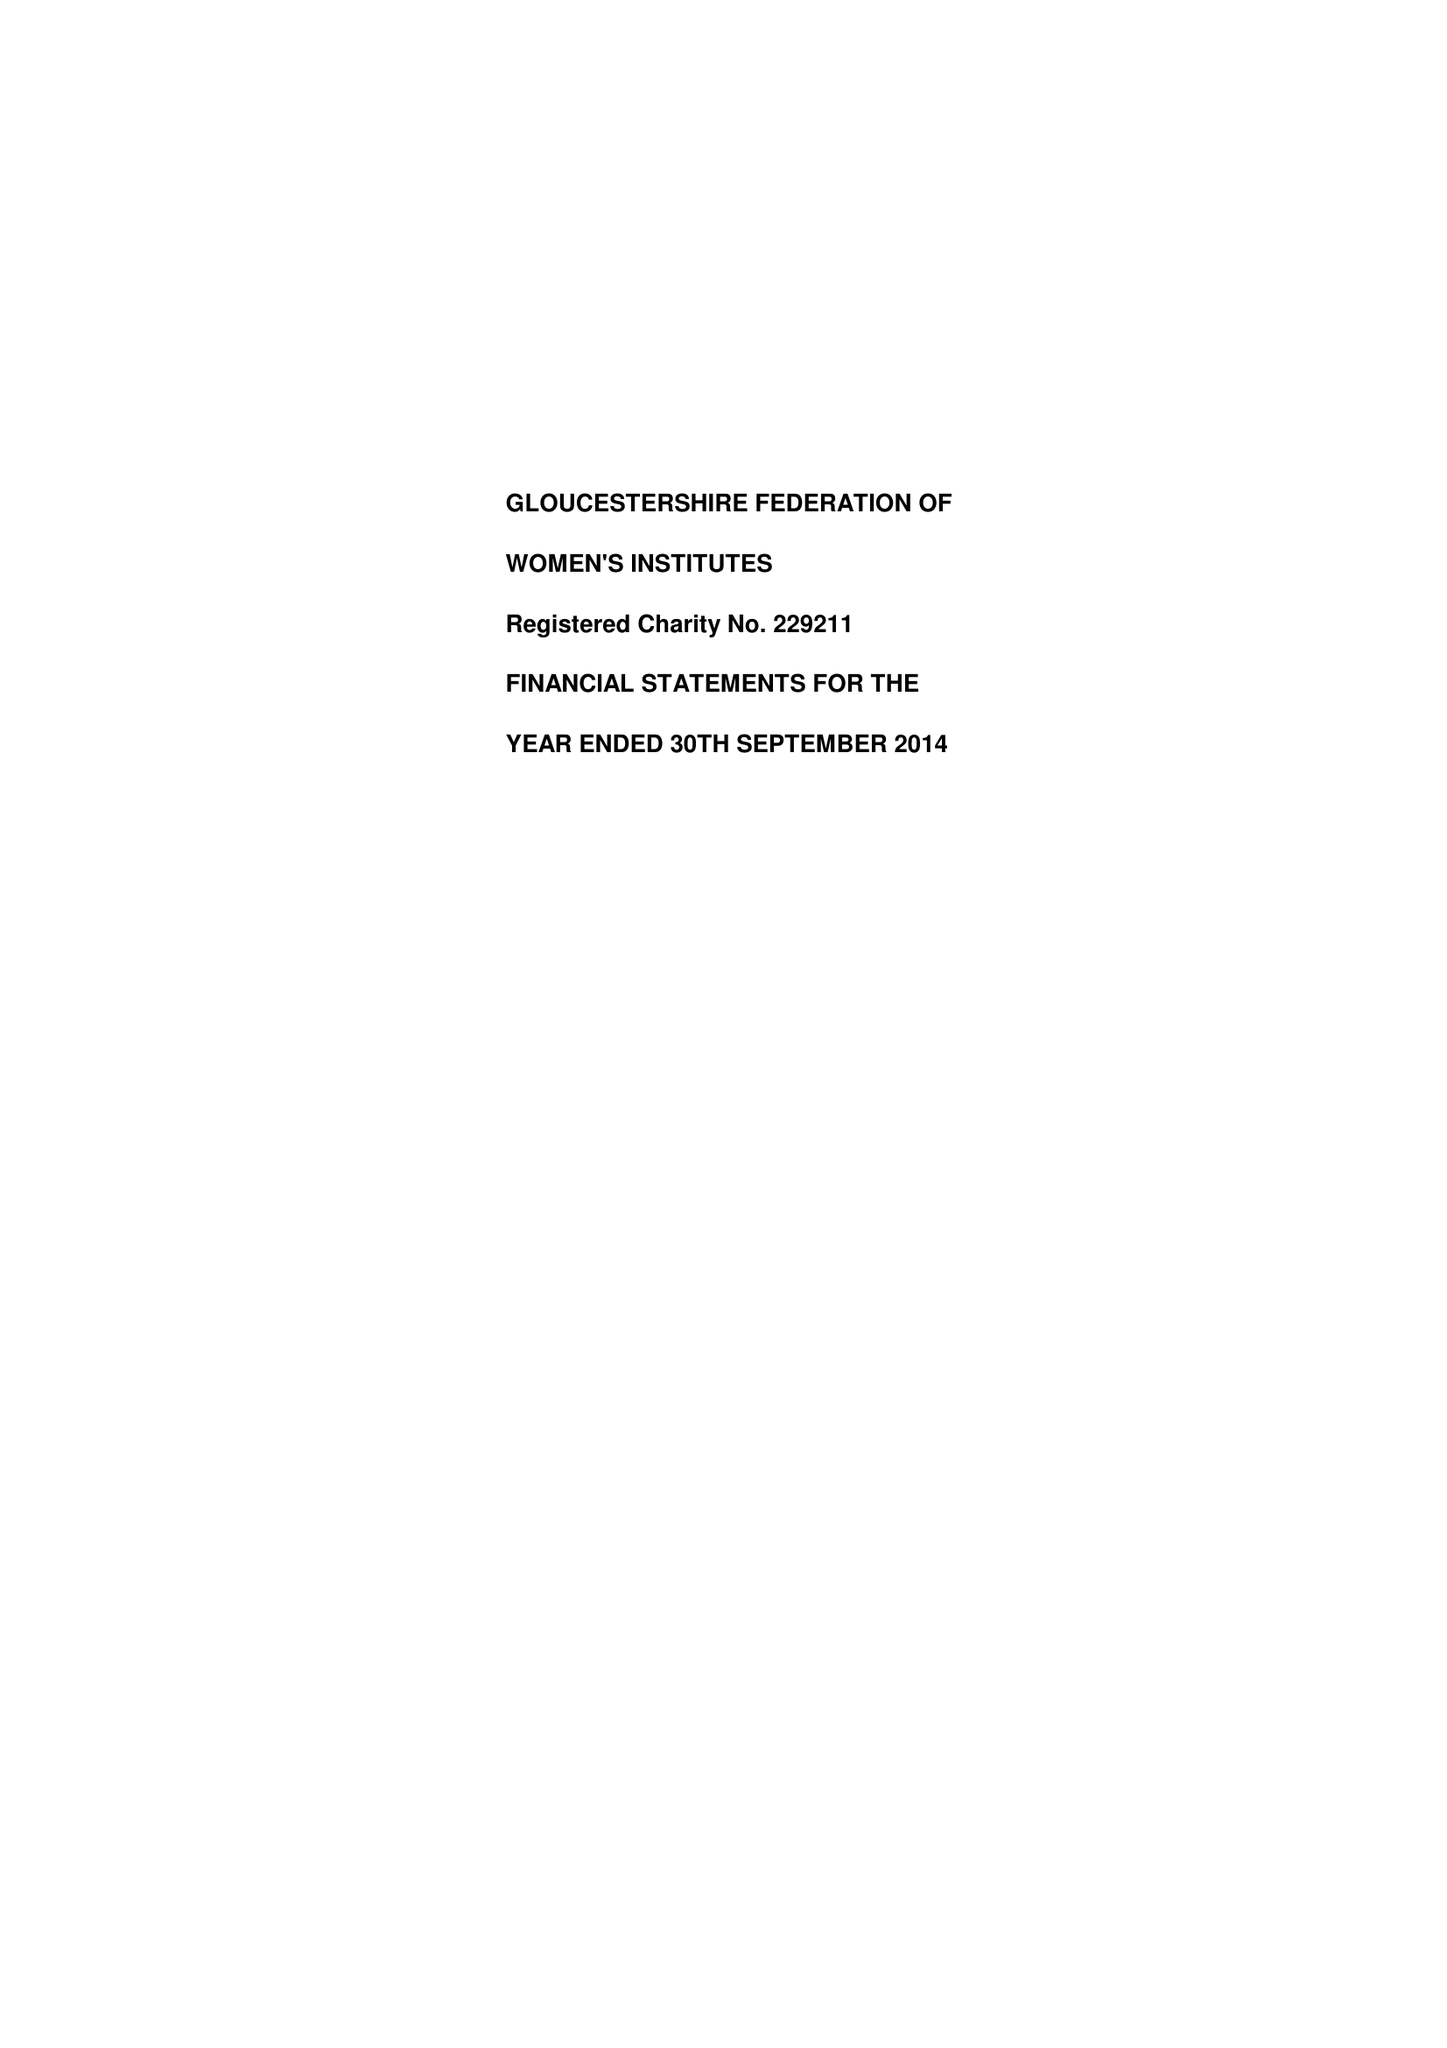What is the value for the report_date?
Answer the question using a single word or phrase. 2014-09-30 